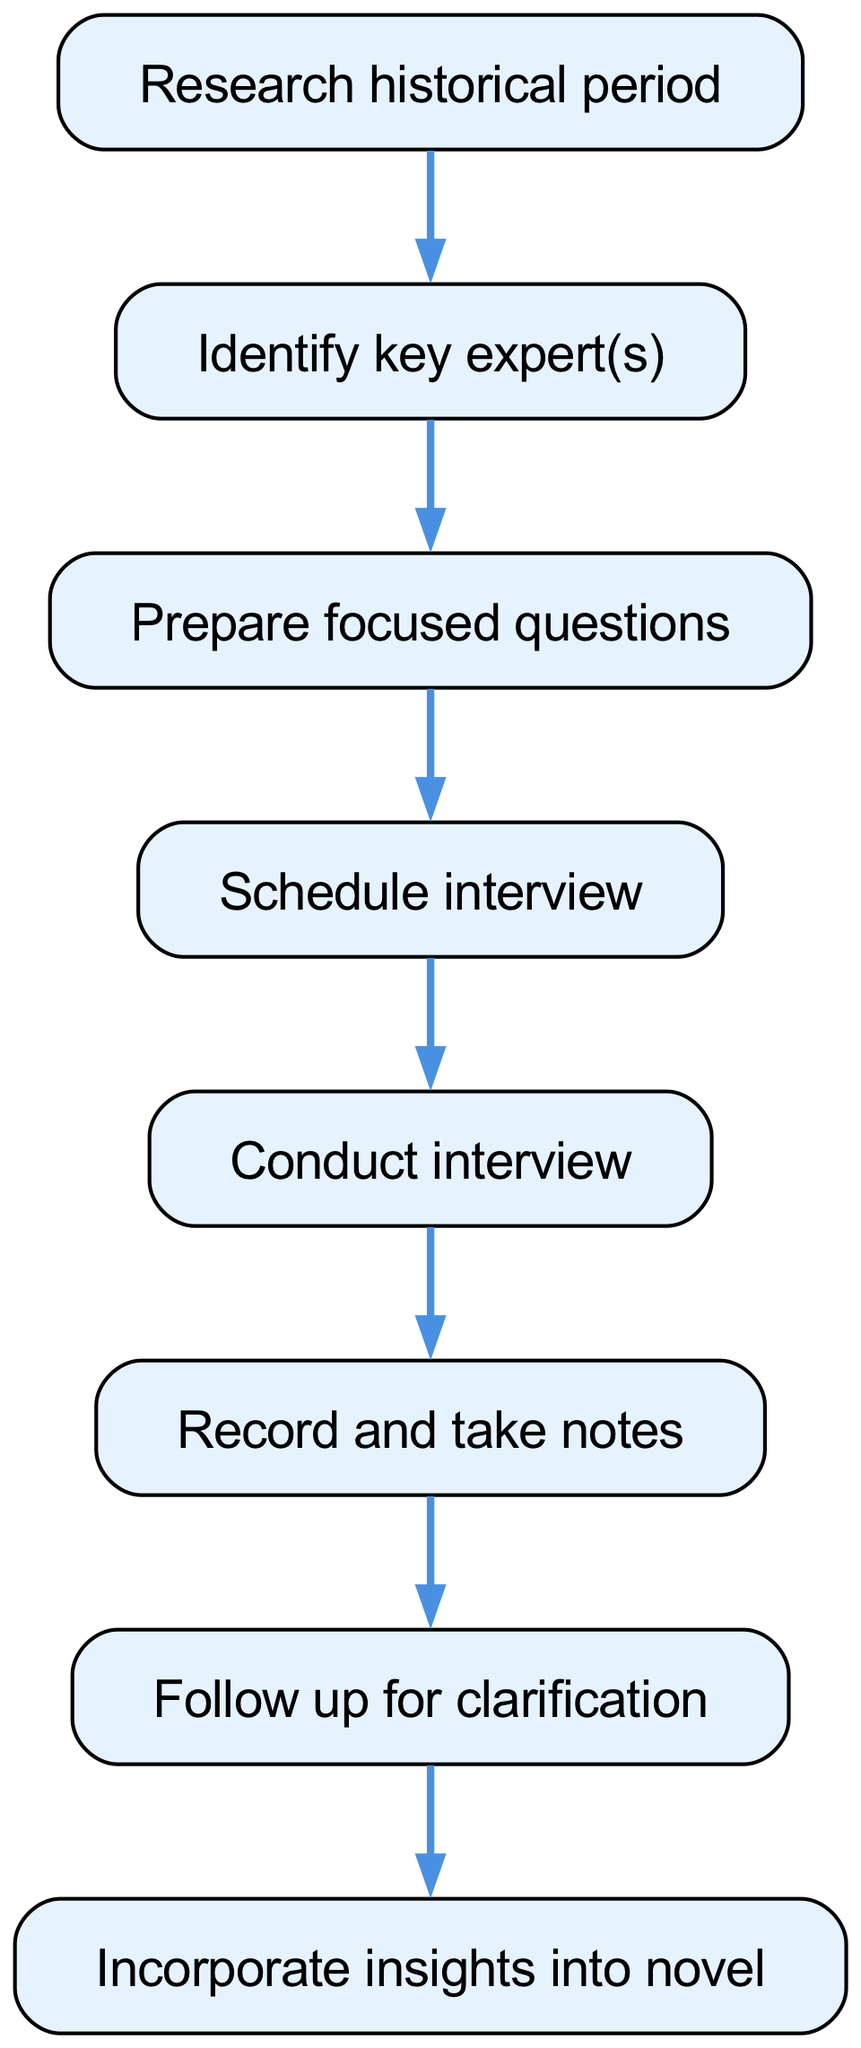What is the first step in the interview process? The diagram starts with the node labeled "Research historical period," which indicates that this is the initial step in conducting an effective interview.
Answer: Research historical period How many steps are there in total? By counting the nodes that represent the steps in the diagram, we find there are 8 distinct steps from start to finish.
Answer: 8 What is the last step in the process? The final node in the diagram is "Incorporate insights into novel," which indicates that this is the concluding step of the process.
Answer: Incorporate insights into novel Which step follows "Prepare focused questions"? According to the flow of the diagram, the step that directly follows "Prepare focused questions" is "Schedule interview" as indicated by the connection between these two nodes.
Answer: Schedule interview What action is taken after "Conduct interview"? The diagram shows that the next action after "Conduct interview" is to "Record and take notes," indicating that note-taking is a crucial follow-up step.
Answer: Record and take notes What is the relationship between "Identify key expert(s)" and "Prepare focused questions"? The flow chart shows that "Identify key expert(s)" leads directly to "Prepare focused questions," establishing a sequential relationship where identifying experts is a prerequisite for preparing questions.
Answer: Sequential relationship What step requires a follow-up action for clarification? The flow chart specifies "Follow up for clarification" as a step that is needed after "Record and take notes," indicating the importance of clarification in the process.
Answer: Follow up for clarification Which step in the process does not have a next step? The flow chart indicates that "Incorporate insights into novel" does not have a following step, signifying it as the endpoint of this instruction flow.
Answer: Incorporate insights into novel 